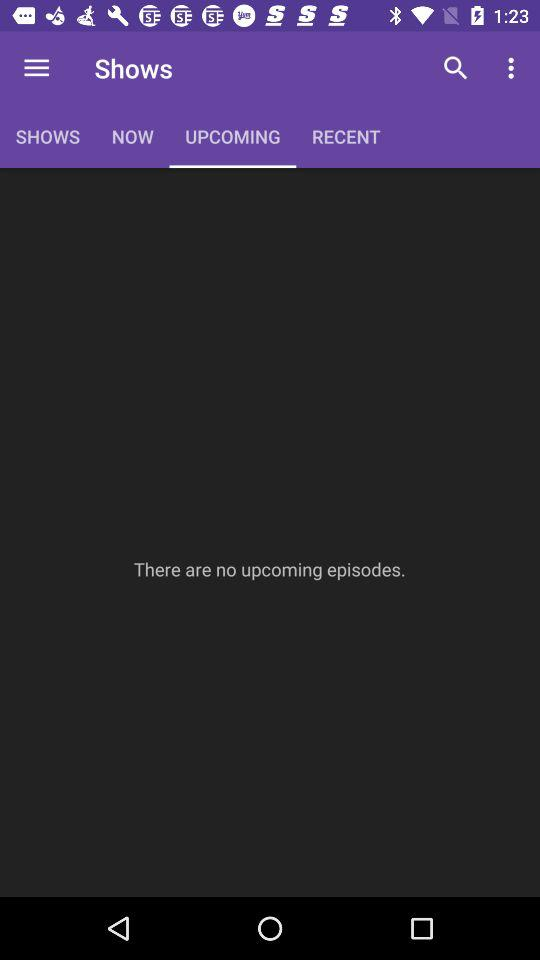How many episodes are available in the Upcomming tab?
Answer the question using a single word or phrase. 0 